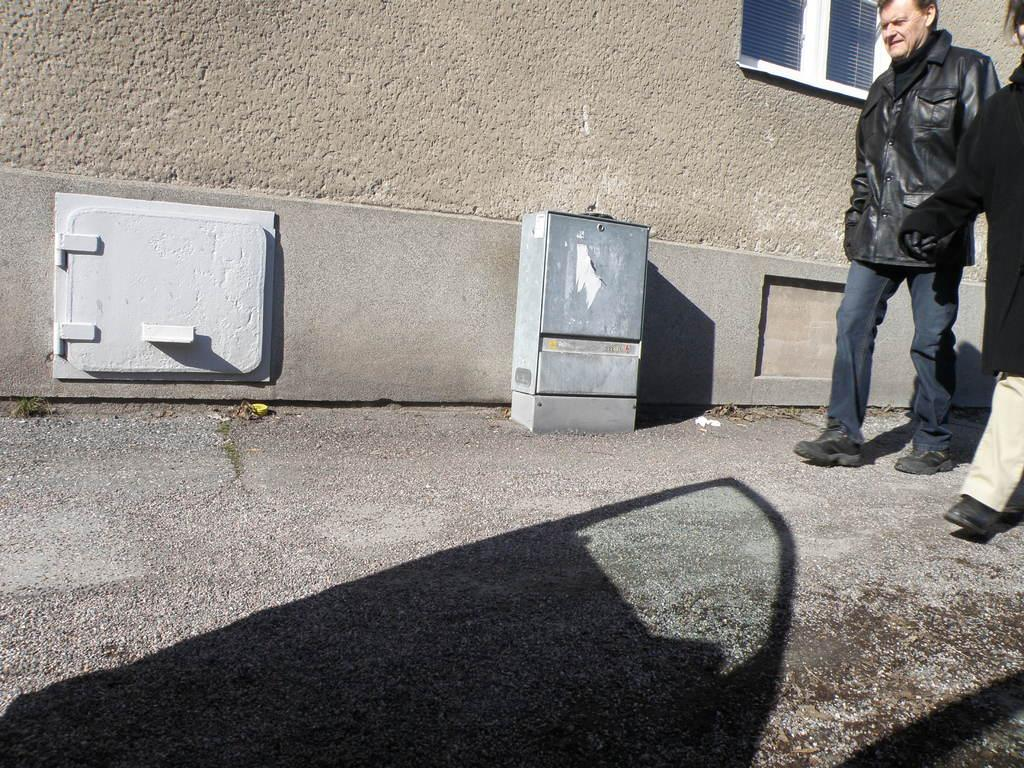What are the two persons in the image doing? The two persons in the image are walking. On which side of the image are the persons walking? The persons are walking on the right side. What can be seen in the background of the image? There is a wall in the background of the image. Can you describe any other features in the image? There is a shadow of a door visible in the image. What type of stocking is the frog wearing in the image? There is no frog or stocking present in the image. How does the anger of the persons affect their walking in the image? There is no indication of anger in the image, and the persons' emotions cannot be determined from their walking. 